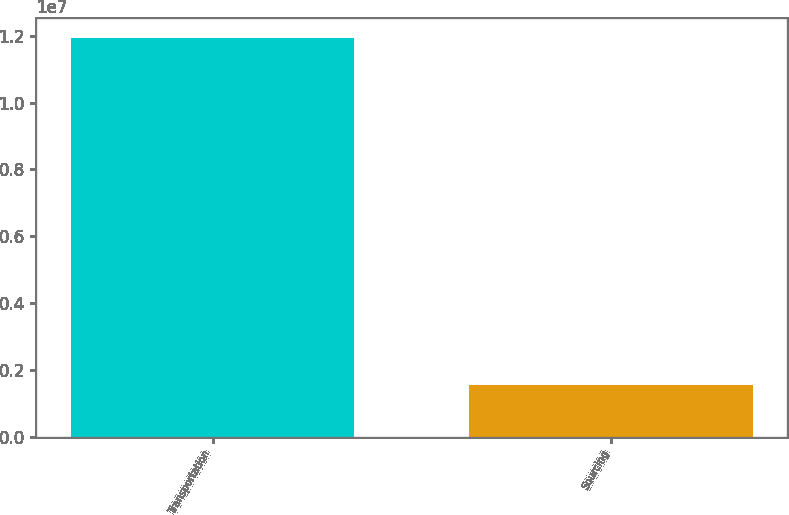Convert chart to OTSL. <chart><loc_0><loc_0><loc_500><loc_500><bar_chart><fcel>Transportation<fcel>Sourcing<nl><fcel>1.19365e+07<fcel>1.53356e+06<nl></chart> 